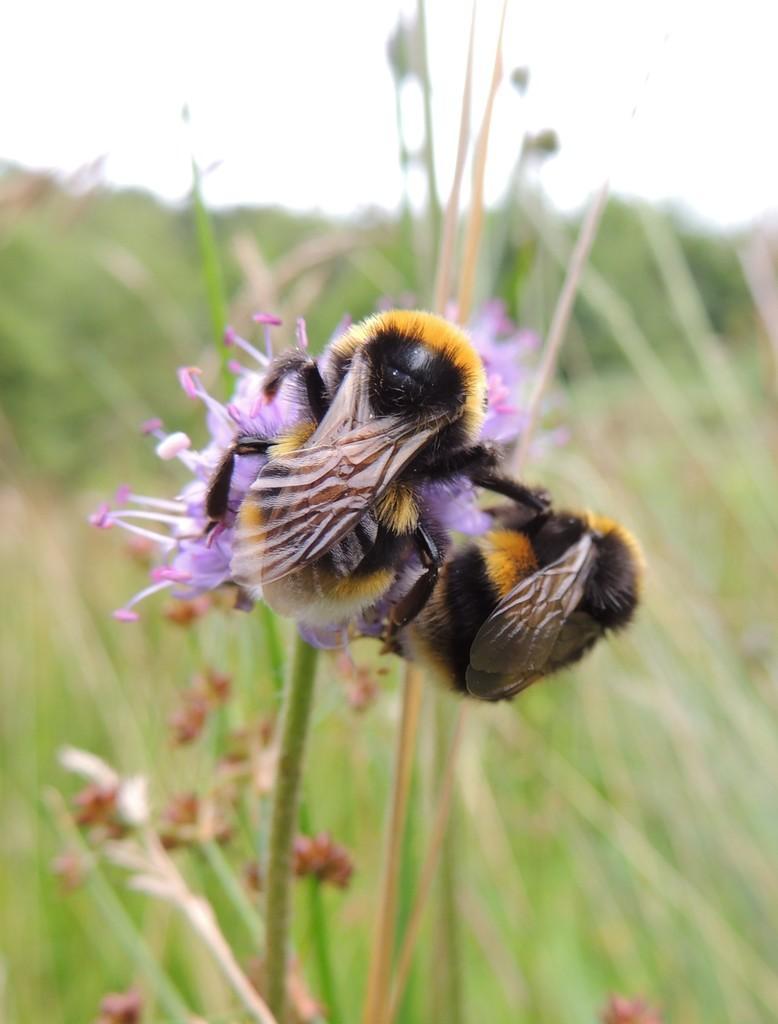Describe this image in one or two sentences. In this image we can see bees, flower, plants and sky. 